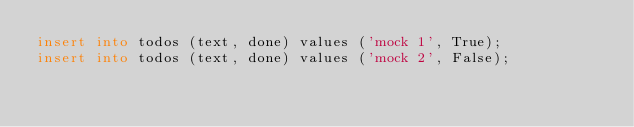Convert code to text. <code><loc_0><loc_0><loc_500><loc_500><_SQL_>insert into todos (text, done) values ('mock 1', True);
insert into todos (text, done) values ('mock 2', False);
</code> 